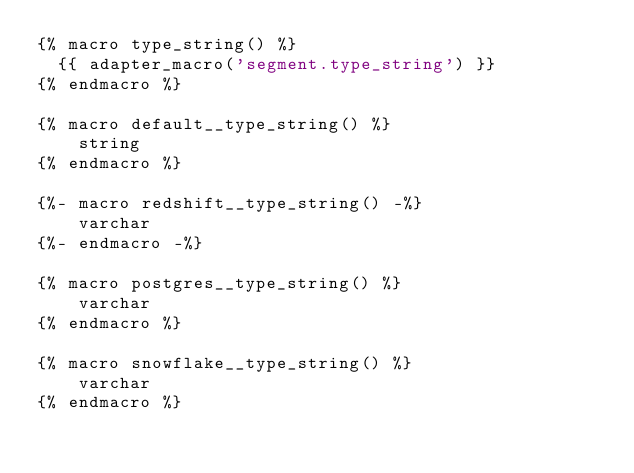Convert code to text. <code><loc_0><loc_0><loc_500><loc_500><_SQL_>{% macro type_string() %}
  {{ adapter_macro('segment.type_string') }}
{% endmacro %}

{% macro default__type_string() %}
    string
{% endmacro %}

{%- macro redshift__type_string() -%}
    varchar
{%- endmacro -%}

{% macro postgres__type_string() %}
    varchar
{% endmacro %}

{% macro snowflake__type_string() %}
    varchar
{% endmacro %}</code> 